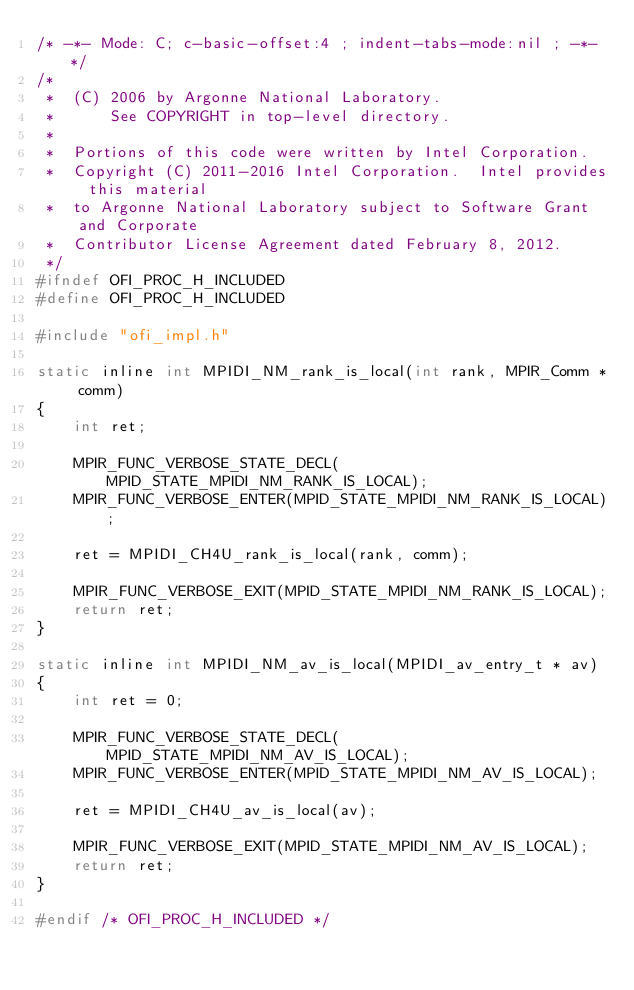Convert code to text. <code><loc_0><loc_0><loc_500><loc_500><_C_>/* -*- Mode: C; c-basic-offset:4 ; indent-tabs-mode:nil ; -*- */
/*
 *  (C) 2006 by Argonne National Laboratory.
 *      See COPYRIGHT in top-level directory.
 *
 *  Portions of this code were written by Intel Corporation.
 *  Copyright (C) 2011-2016 Intel Corporation.  Intel provides this material
 *  to Argonne National Laboratory subject to Software Grant and Corporate
 *  Contributor License Agreement dated February 8, 2012.
 */
#ifndef OFI_PROC_H_INCLUDED
#define OFI_PROC_H_INCLUDED

#include "ofi_impl.h"

static inline int MPIDI_NM_rank_is_local(int rank, MPIR_Comm * comm)
{
    int ret;

    MPIR_FUNC_VERBOSE_STATE_DECL(MPID_STATE_MPIDI_NM_RANK_IS_LOCAL);
    MPIR_FUNC_VERBOSE_ENTER(MPID_STATE_MPIDI_NM_RANK_IS_LOCAL);

    ret = MPIDI_CH4U_rank_is_local(rank, comm);

    MPIR_FUNC_VERBOSE_EXIT(MPID_STATE_MPIDI_NM_RANK_IS_LOCAL);
    return ret;
}

static inline int MPIDI_NM_av_is_local(MPIDI_av_entry_t * av)
{
    int ret = 0;

    MPIR_FUNC_VERBOSE_STATE_DECL(MPID_STATE_MPIDI_NM_AV_IS_LOCAL);
    MPIR_FUNC_VERBOSE_ENTER(MPID_STATE_MPIDI_NM_AV_IS_LOCAL);

    ret = MPIDI_CH4U_av_is_local(av);

    MPIR_FUNC_VERBOSE_EXIT(MPID_STATE_MPIDI_NM_AV_IS_LOCAL);
    return ret;
}

#endif /* OFI_PROC_H_INCLUDED */
</code> 